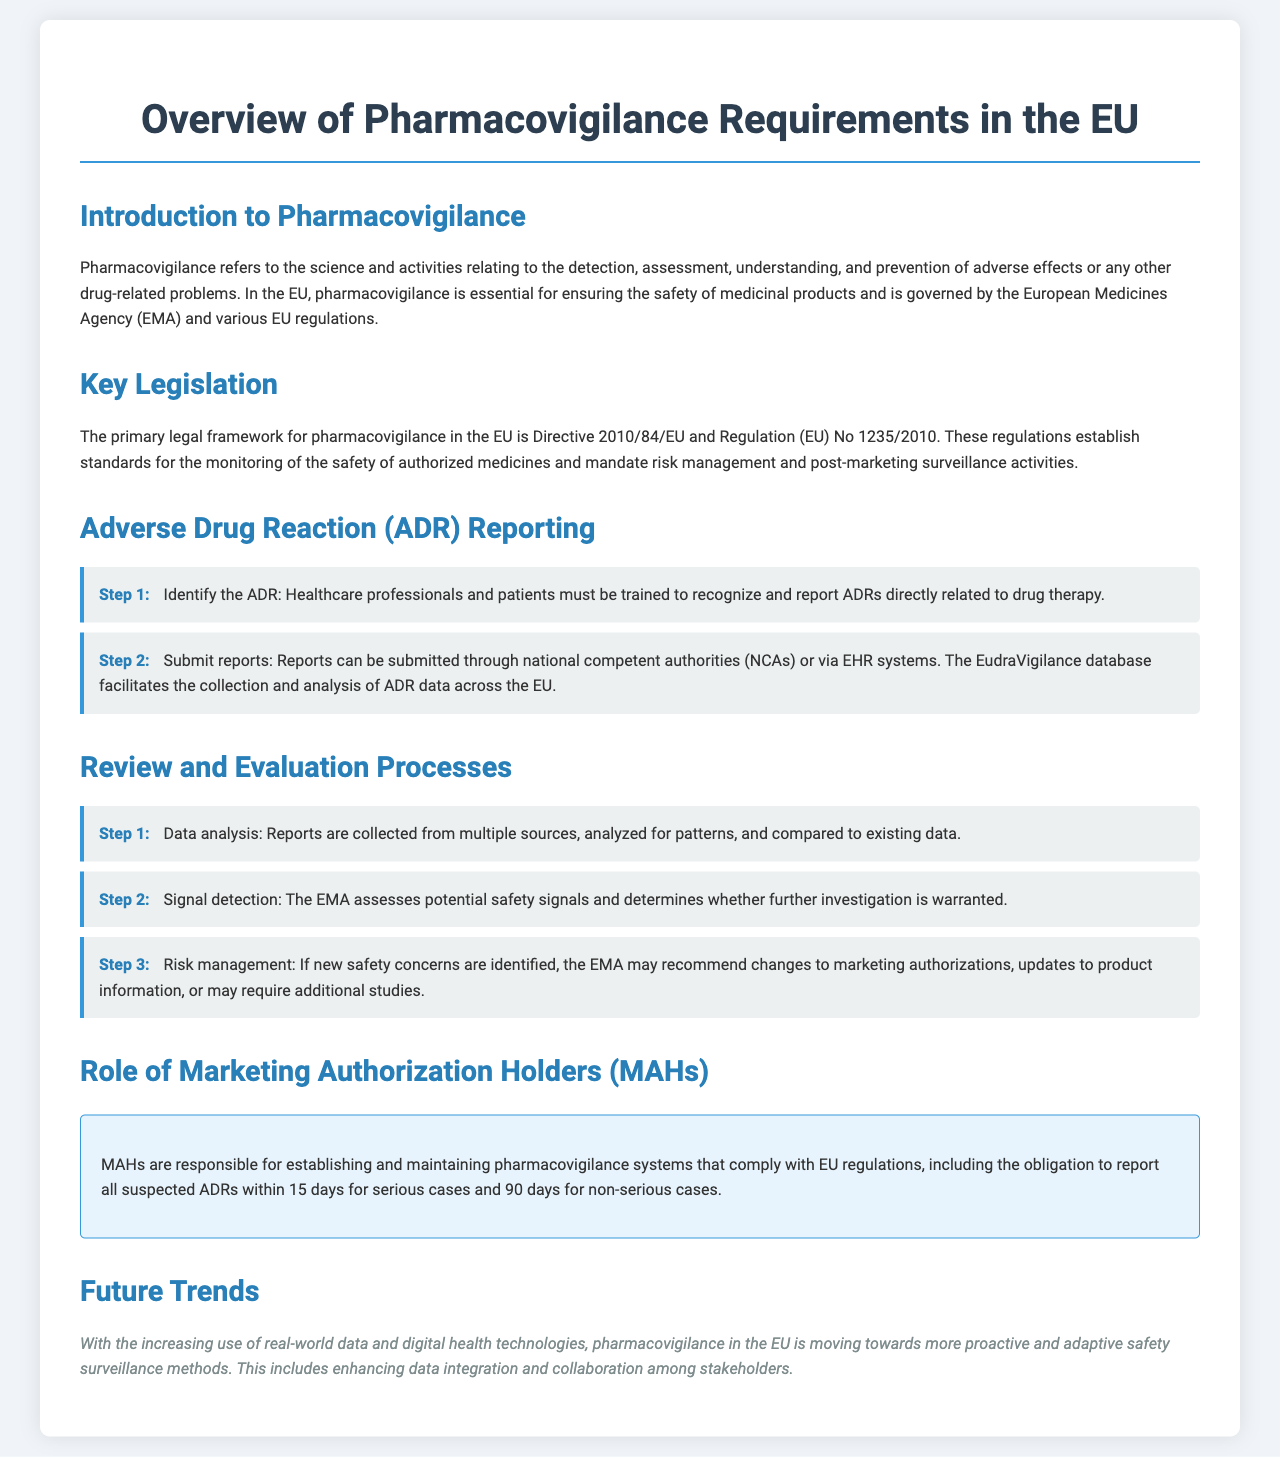What is the primary legal framework for pharmacovigilance in the EU? The primary legal framework is Directive 2010/84/EU and Regulation (EU) No 1235/2010.
Answer: Directive 2010/84/EU and Regulation (EU) No 1235/2010 What is needed to identify an ADR? Healthcare professionals and patients must be trained to recognize and report ADRs directly related to drug therapy.
Answer: Training What is the time frame for reporting serious ADRs by MAHs? MAHs must report all suspected serious ADRs within 15 days.
Answer: 15 days Which database facilitates the collection and analysis of ADR data? The EudraVigilance database facilitates the collection and analysis of ADR data across the EU.
Answer: EudraVigilance What is the first step in the review and evaluation process? The first step is data analysis.
Answer: Data analysis What risk management action may the EMA take if new safety concerns are identified? The EMA may recommend changes to marketing authorizations, updates to product information, or may require additional studies.
Answer: Changes to marketing authorizations How does pharmacovigilance in the EU plan to adapt in the future? It plans to move towards more proactive and adaptive safety surveillance methods.
Answer: Proactive safety surveillance What is the role of MAHs in pharmacovigilance? MAHs are responsible for establishing and maintaining pharmacovigilance systems that comply with EU regulations.
Answer: Establishing and maintaining systems 